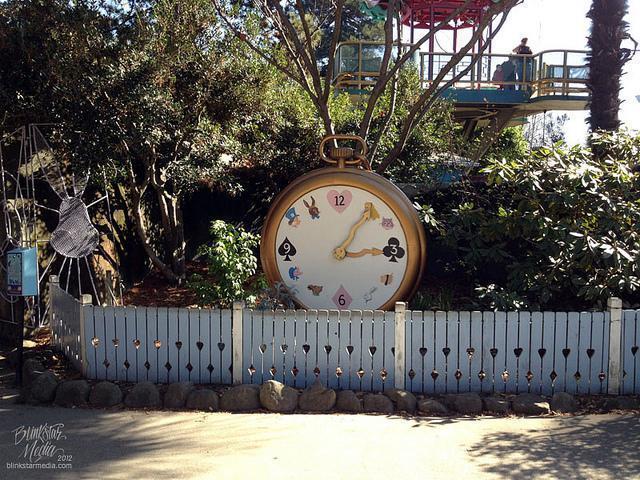This area is based on which author's works?
Choose the correct response, then elucidate: 'Answer: answer
Rationale: rationale.'
Options: Lewis carroll, agatha christie, mark twain, stephen king. Answer: lewis carroll.
Rationale: Lewis carroll wrote through the looking glass. 